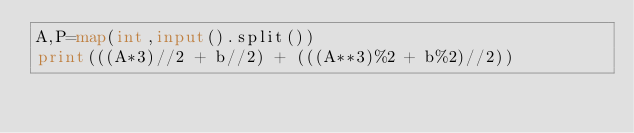Convert code to text. <code><loc_0><loc_0><loc_500><loc_500><_Python_>A,P=map(int,input().split())
print(((A*3)//2 + b//2) + (((A**3)%2 + b%2)//2))</code> 